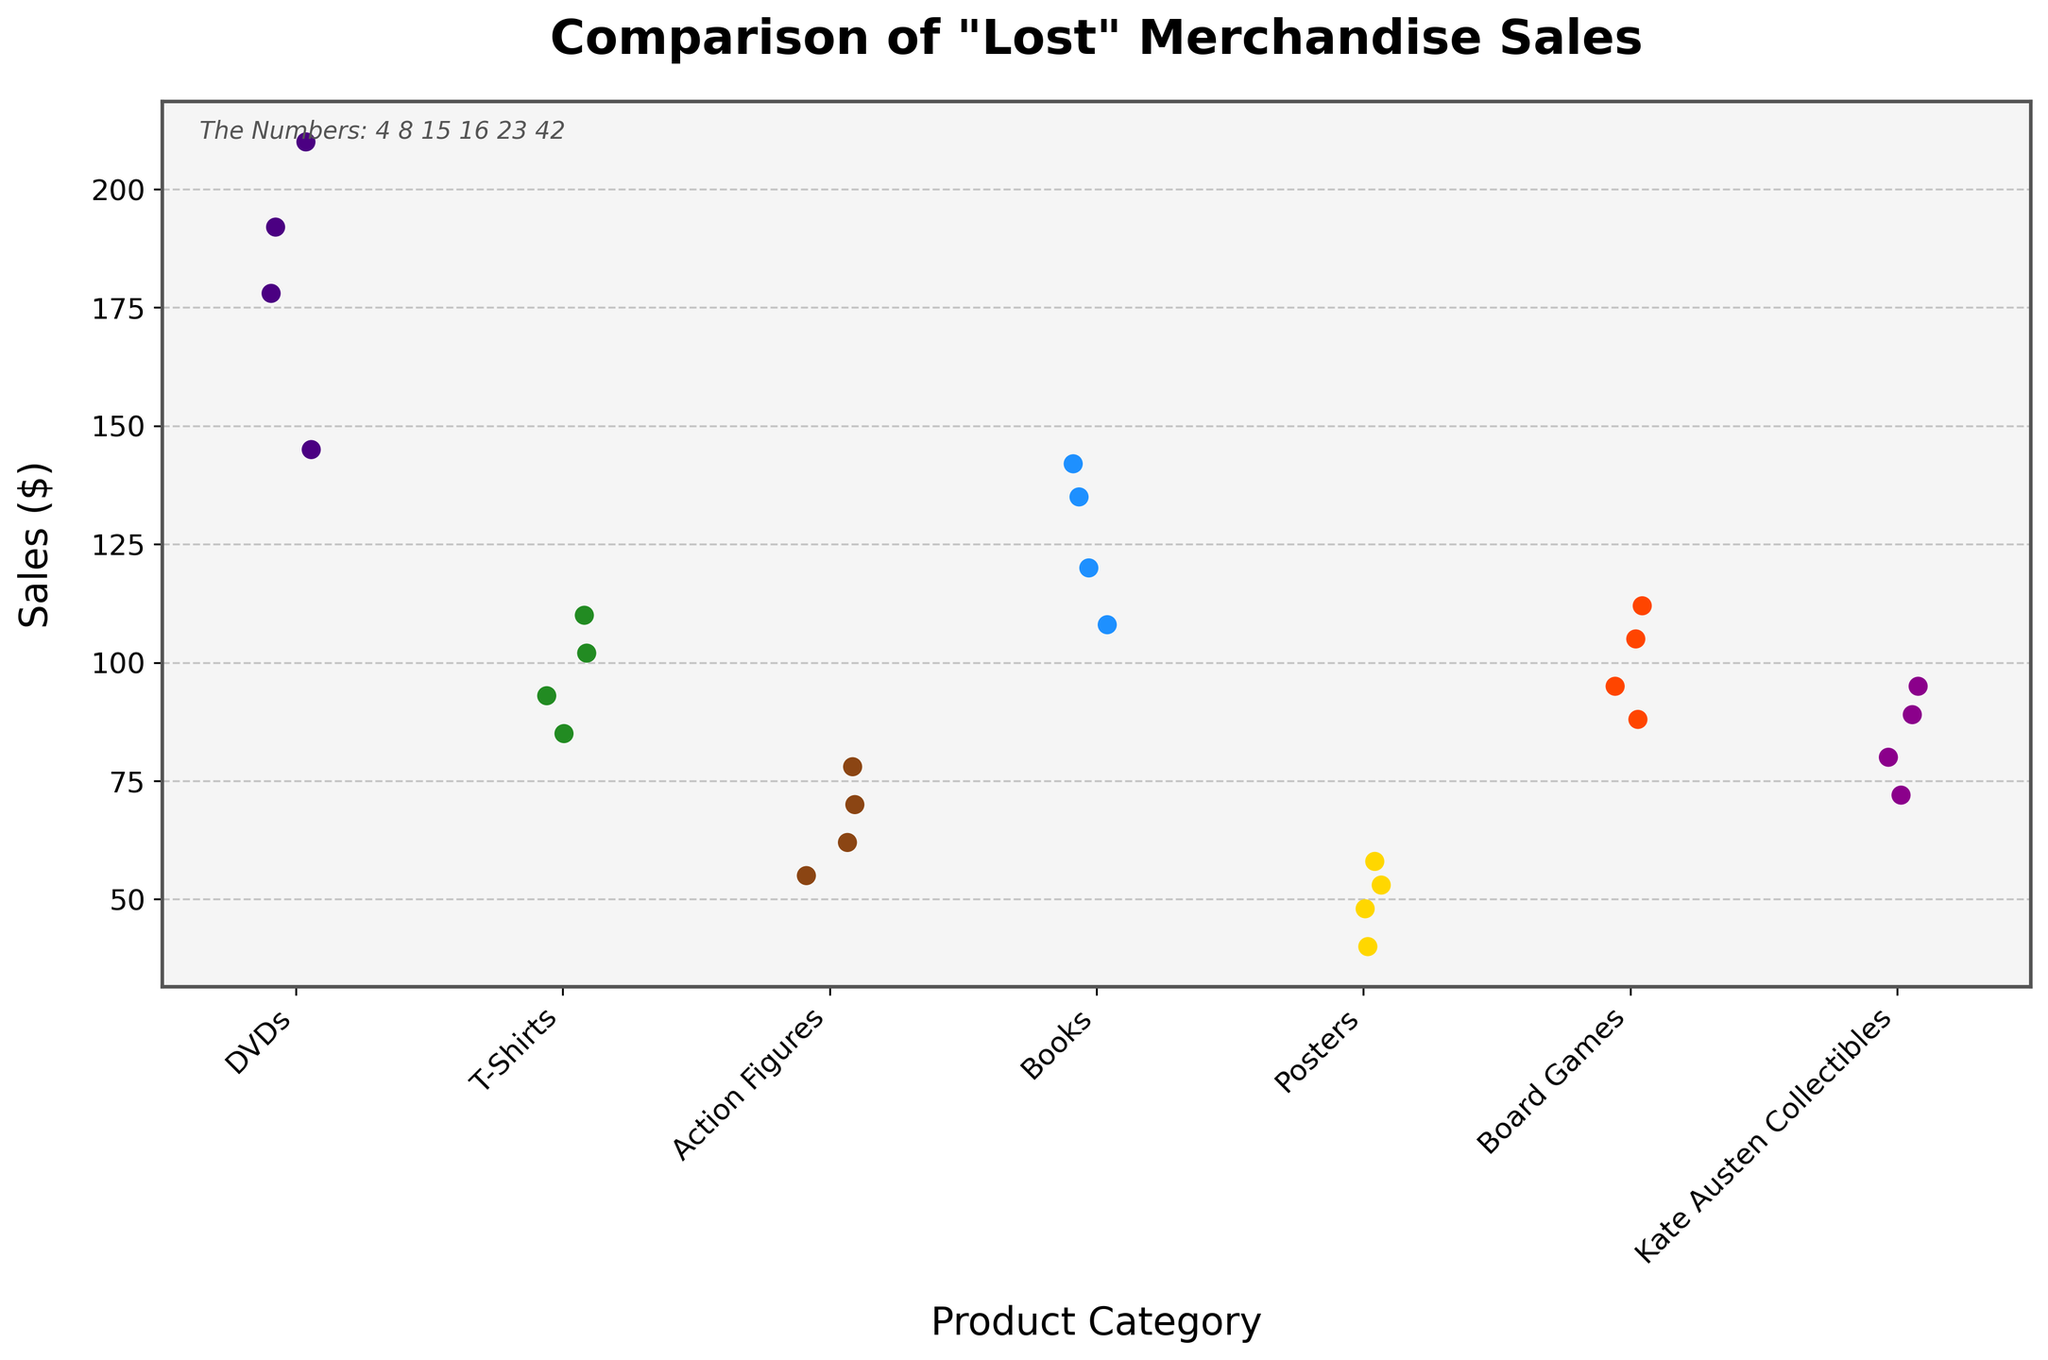What is the title of the plot? The title of the plot is usually located at the top center of the figure. In this case, it says "Comparison of 'Lost' Merchandise Sales".
Answer: Comparison of "Lost" Merchandise Sales How many product categories are displayed? Count the distinct groups presented on the x-axis of the strip plot. Each unique label like "DVDs", "T-Shirts", "Action Figures", etc. represents a product category. There are 7 unique categories.
Answer: 7 What is the sales range for DVDs? Identify the lowest and highest points of the data points under the "DVDs" category on the y-axis. The lowest sales number is 145 and the highest is 210.
Answer: 145 - 210 Which category has the lowest overall sales? Look at the y-axis values of all data points in each category and identify the category with the overall lowest sales. The lowest sales appear in the "Posters" category.
Answer: Posters How do the sales of Kate Austen Collectibles compare with T-Shirts? Compare the range and distribution of data points for "Kate Austen Collectibles" and "T-Shirts". Kate Austen Collectibles have sales ranging from 72 to 95, while T-Shirts range from 85 to 110.
Answer: Kate Austen Collectibles have generally lower sales than T-Shirts What is the median sales value for Books? Arrange the sales figures of the "Books" category in ascending order: 108, 120, 135, 142. The median value is the average of the two middle values: (120 + 135) / 2.
Answer: 127.5 Which category appears to have the most consistent sales? The consistency of sales can be judged by the spread of data points. Categories with tightly clustered points are more consistent. The DVDs category shows closely packed data points.
Answer: DVDs How many data points are there for each category? Count the number of data points (individual dots) under each category. By inspecting the plot, each category contains 4 data points.
Answer: 4 What is the sales value at the highest point for Board Games? Identify the highest individual data point on the y-axis under the "Board Games" category. The highest sales value is 112.
Answer: 112 What are the color palettes used in the figure? Note the colors used for each category in the plot. The colors are likely inspired by the "Lost" island and may include shades like deep purples, greens, browns, blues, golds, reds, and magentas. Although exact names aren't typically given, the colors provide a visual cue.
Answer: Purple, green, brown, blue, gold, red, magenta 